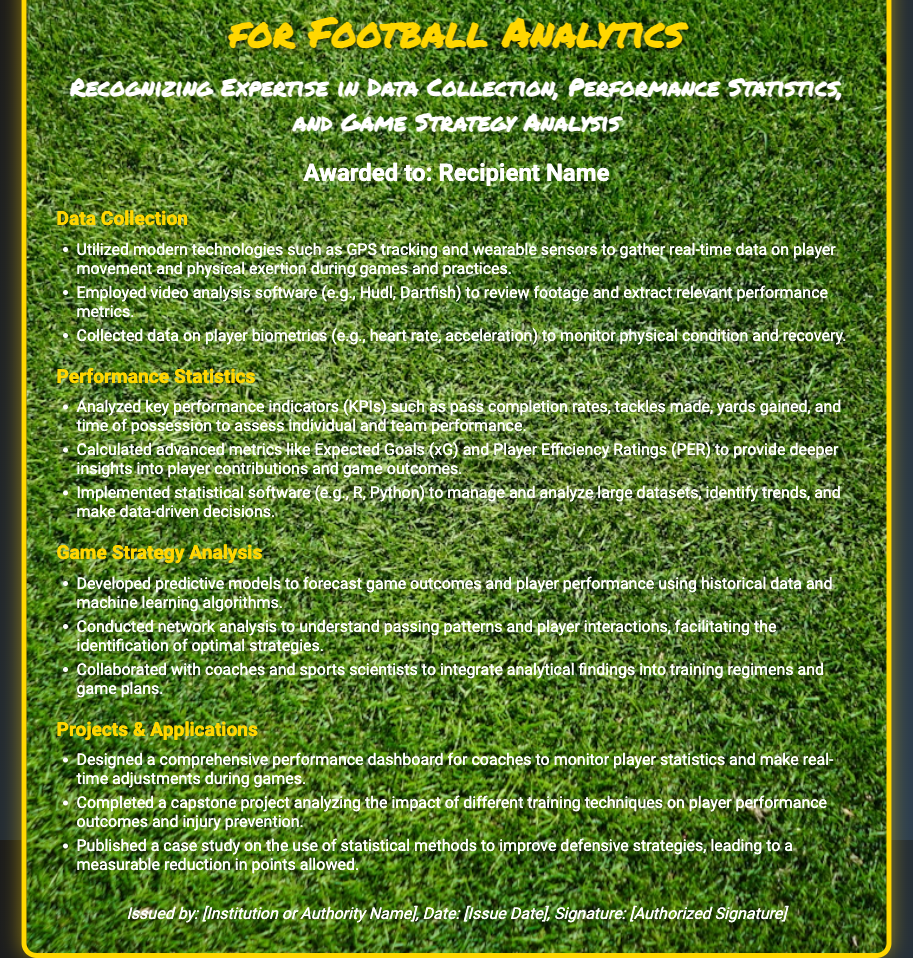What is the title of the certificate? The title is the foremost prominent text indicating what the document certifies, which is found at the top of the certificate.
Answer: Certificate of Distinction in Statistics for Football Analytics Who is the certificate awarded to? The recipient's name is stated directly below the title, indicating the person who received the certificate.
Answer: Recipient Name What technology is used for data collection? The document lists specific technologies under the data collection section, mentioning what is utilized for gathering data.
Answer: GPS tracking What statistical software is mentioned for analyzing performance? The performance statistics section includes the tools that are used for data management and analysis.
Answer: R What was one of the projects completed as mentioned in the document? The projects and applications section describes various initiatives undertaken, including one notable capstone project.
Answer: Analyzing the impact of different training techniques What color is the border of the certificate? The description of the certificate design explicitly states the color of the border surrounding the main content area.
Answer: Gold What is one advanced metric calculated for deeper insights? The performance statistics section lists advanced metrics, one of which provides enhanced player contribution understanding.
Answer: Expected Goals (xG) Which section includes the use of machine learning algorithms? The game strategy analysis section discusses methodologies and techniques that incorporate advanced computational tools, including machine learning.
Answer: Game Strategy Analysis Who issued the certificate? At the bottom of the document, this information is provided, usually indicating the authority responsible for the certification.
Answer: [Institution or Authority Name] 